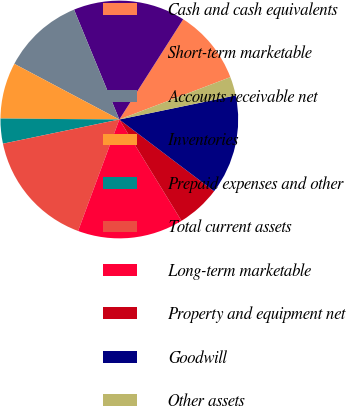Convert chart to OTSL. <chart><loc_0><loc_0><loc_500><loc_500><pie_chart><fcel>Cash and cash equivalents<fcel>Short-term marketable<fcel>Accounts receivable net<fcel>Inventories<fcel>Prepaid expenses and other<fcel>Total current assets<fcel>Long-term marketable<fcel>Property and equipment net<fcel>Goodwill<fcel>Other assets<nl><fcel>10.17%<fcel>15.25%<fcel>11.02%<fcel>7.63%<fcel>3.39%<fcel>16.1%<fcel>14.4%<fcel>5.93%<fcel>13.56%<fcel>2.55%<nl></chart> 